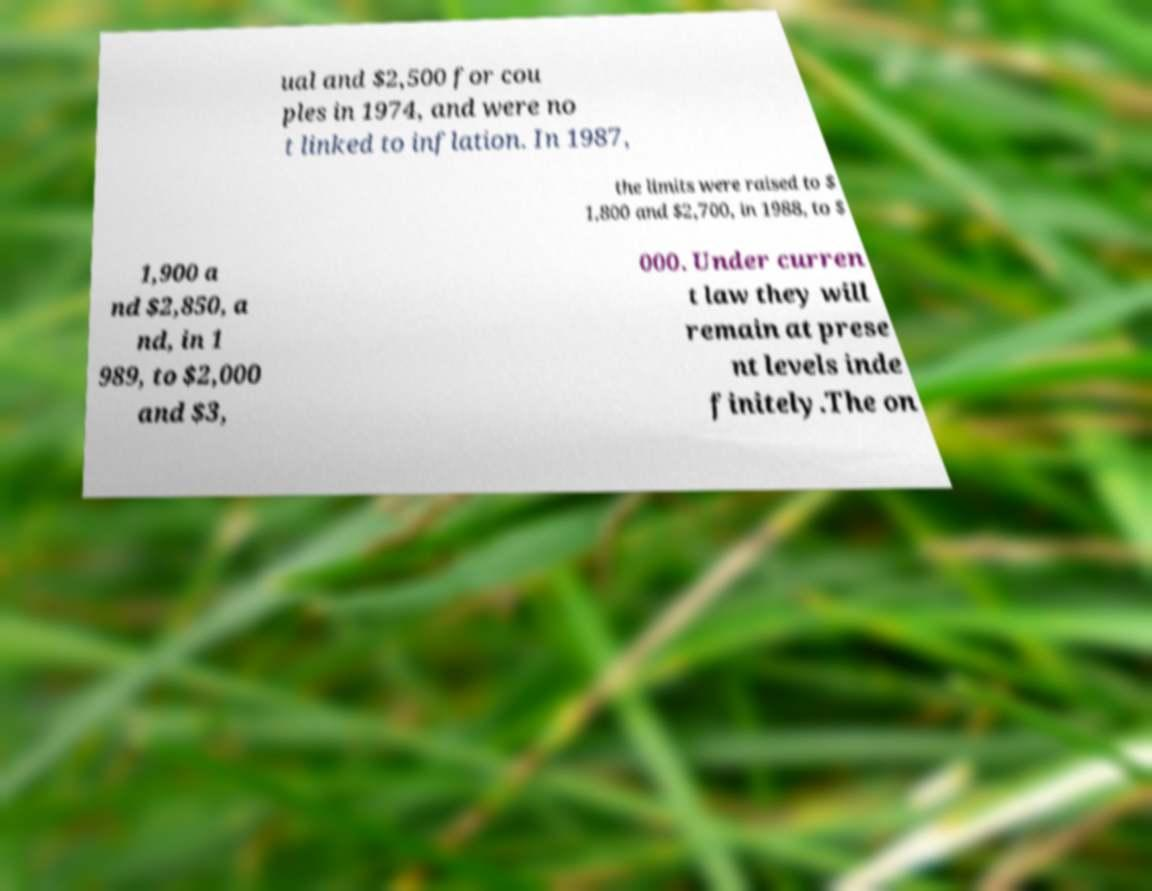Please identify and transcribe the text found in this image. ual and $2,500 for cou ples in 1974, and were no t linked to inflation. In 1987, the limits were raised to $ 1,800 and $2,700, in 1988, to $ 1,900 a nd $2,850, a nd, in 1 989, to $2,000 and $3, 000. Under curren t law they will remain at prese nt levels inde finitely.The on 